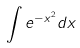Convert formula to latex. <formula><loc_0><loc_0><loc_500><loc_500>\int e ^ { - x ^ { 2 } } d x</formula> 